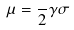<formula> <loc_0><loc_0><loc_500><loc_500>\mu = \frac { } { 2 } \gamma \sigma</formula> 